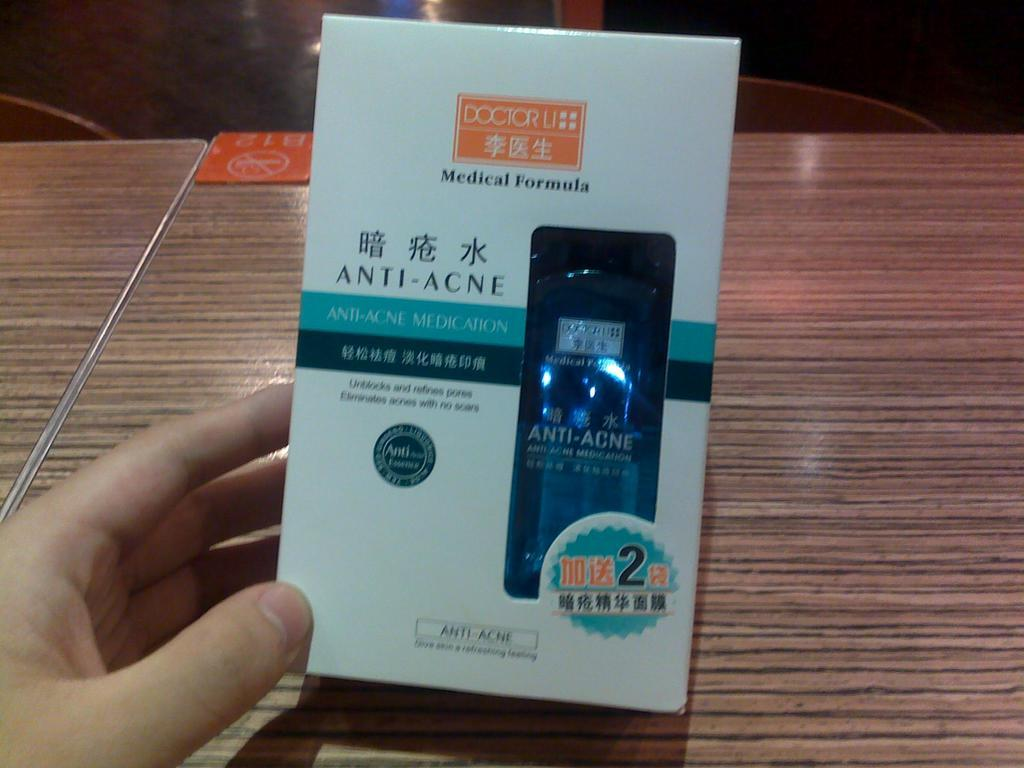<image>
Relay a brief, clear account of the picture shown. Someone is holding a box of Anti-Acne treatment made by Doctor Li. 